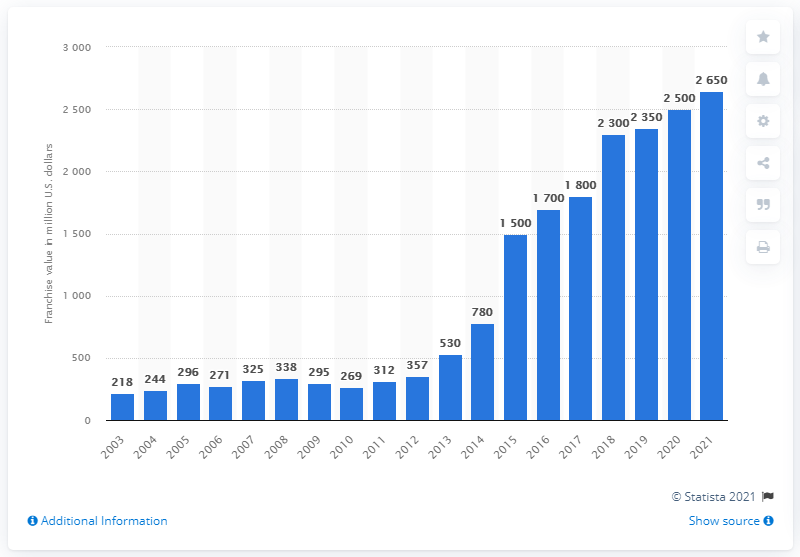Highlight a few significant elements in this photo. In 2021, the estimated value of the Brooklyn Nets was $2,650 million. 